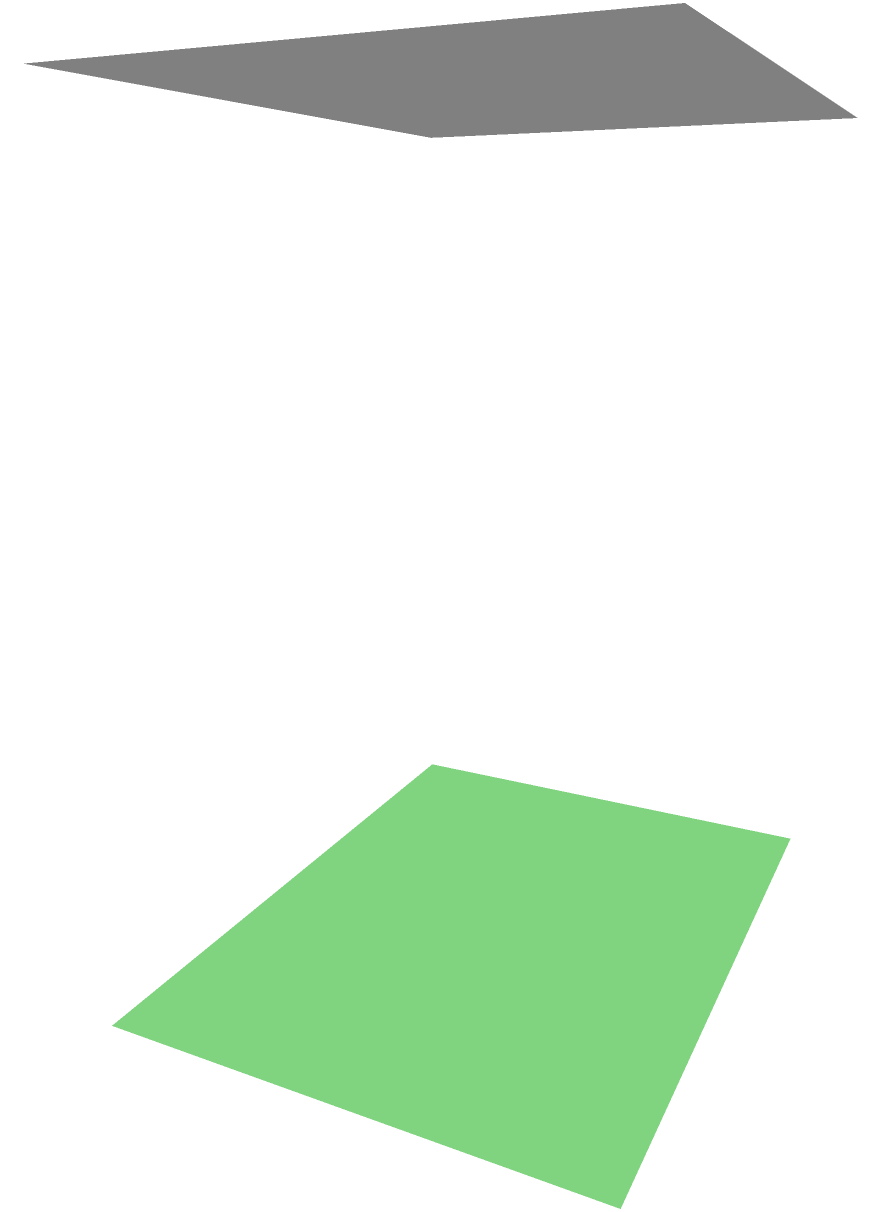As part of a secret mission, you need to compute the lateral surface area of a prismatic underground bunker. The bunker has a rectangular base with dimensions $a = 4$ units and $b = 3$ units, and a height of $h = 5$ units. Calculate the lateral surface area of the bunker. To calculate the lateral surface area of a prismatic bunker, we need to follow these steps:

1. Identify the shape: The bunker is a rectangular prism.

2. Recall the formula for lateral surface area of a rectangular prism:
   Lateral Surface Area = 2h(a + b), where h is the height, and a and b are the base dimensions.

3. Substitute the given values:
   a = 4 units
   b = 3 units
   h = 5 units

4. Calculate:
   Lateral Surface Area = 2 * 5 * (4 + 3)
                        = 2 * 5 * 7
                        = 10 * 7
                        = 70 square units

Therefore, the lateral surface area of the secret underground bunker is 70 square units.
Answer: 70 square units 